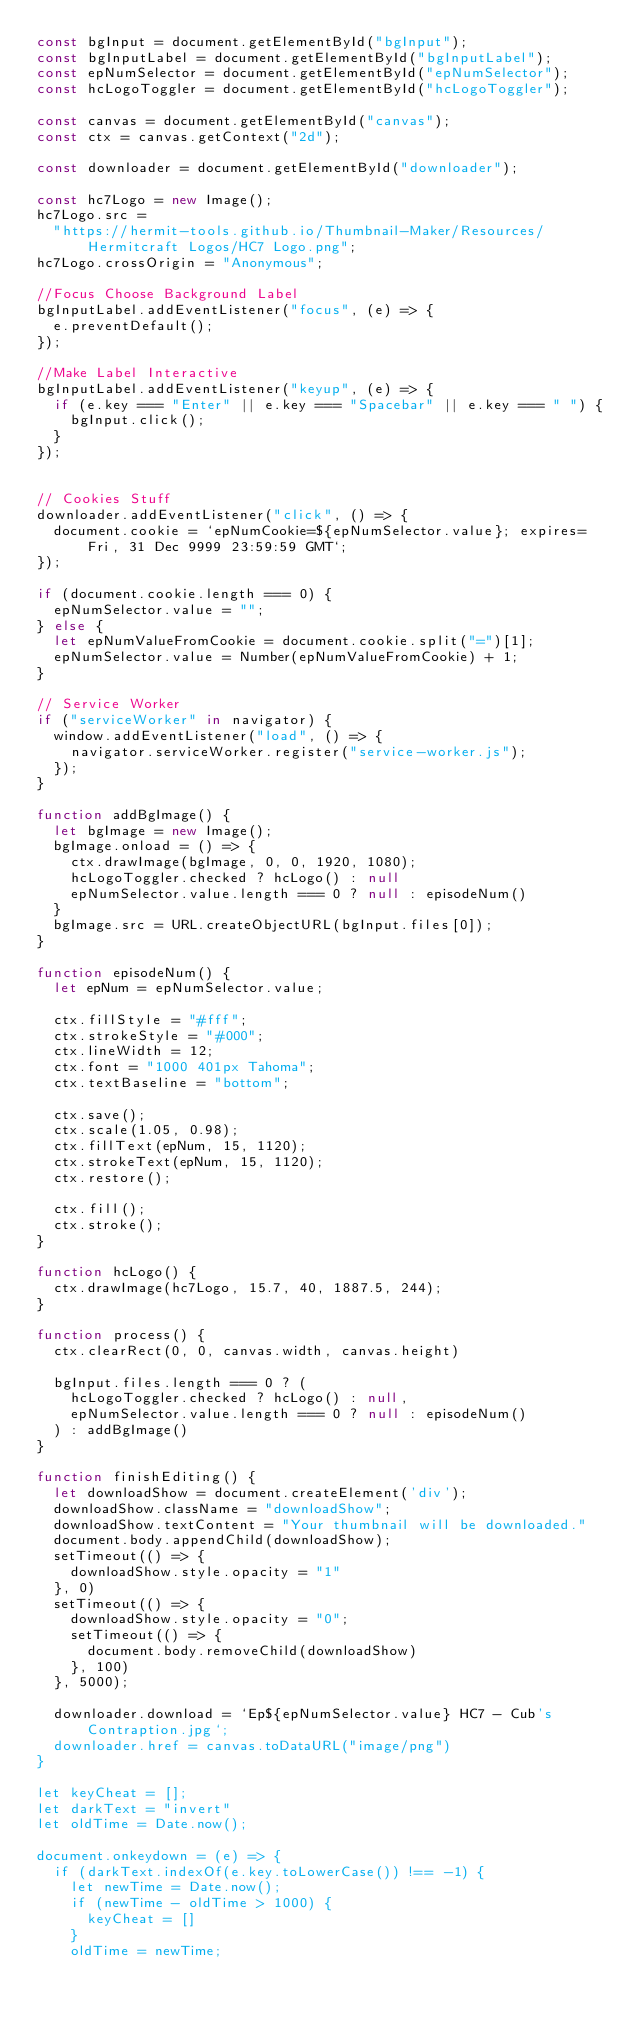Convert code to text. <code><loc_0><loc_0><loc_500><loc_500><_JavaScript_>const bgInput = document.getElementById("bgInput");
const bgInputLabel = document.getElementById("bgInputLabel");
const epNumSelector = document.getElementById("epNumSelector");
const hcLogoToggler = document.getElementById("hcLogoToggler");

const canvas = document.getElementById("canvas");
const ctx = canvas.getContext("2d");

const downloader = document.getElementById("downloader");

const hc7Logo = new Image();
hc7Logo.src =
  "https://hermit-tools.github.io/Thumbnail-Maker/Resources/Hermitcraft Logos/HC7 Logo.png";
hc7Logo.crossOrigin = "Anonymous";

//Focus Choose Background Label
bgInputLabel.addEventListener("focus", (e) => {
  e.preventDefault();
});

//Make Label Interactive
bgInputLabel.addEventListener("keyup", (e) => {
  if (e.key === "Enter" || e.key === "Spacebar" || e.key === " ") {
    bgInput.click();
  }
});


// Cookies Stuff
downloader.addEventListener("click", () => {
  document.cookie = `epNumCookie=${epNumSelector.value}; expires=Fri, 31 Dec 9999 23:59:59 GMT`;
});

if (document.cookie.length === 0) {
  epNumSelector.value = "";
} else {
  let epNumValueFromCookie = document.cookie.split("=")[1];
  epNumSelector.value = Number(epNumValueFromCookie) + 1;
}

// Service Worker
if ("serviceWorker" in navigator) {
  window.addEventListener("load", () => {
    navigator.serviceWorker.register("service-worker.js");
  });
}

function addBgImage() {
  let bgImage = new Image();
  bgImage.onload = () => {
    ctx.drawImage(bgImage, 0, 0, 1920, 1080);
    hcLogoToggler.checked ? hcLogo() : null
    epNumSelector.value.length === 0 ? null : episodeNum()
  }
  bgImage.src = URL.createObjectURL(bgInput.files[0]);
}

function episodeNum() {
  let epNum = epNumSelector.value;

  ctx.fillStyle = "#fff";
  ctx.strokeStyle = "#000";
  ctx.lineWidth = 12;
  ctx.font = "1000 401px Tahoma";
  ctx.textBaseline = "bottom";

  ctx.save();
  ctx.scale(1.05, 0.98);
  ctx.fillText(epNum, 15, 1120);
  ctx.strokeText(epNum, 15, 1120);
  ctx.restore();

  ctx.fill();
  ctx.stroke();
}

function hcLogo() {
  ctx.drawImage(hc7Logo, 15.7, 40, 1887.5, 244);
}

function process() {
  ctx.clearRect(0, 0, canvas.width, canvas.height)

  bgInput.files.length === 0 ? (
    hcLogoToggler.checked ? hcLogo() : null,
    epNumSelector.value.length === 0 ? null : episodeNum()
  ) : addBgImage()
}

function finishEditing() {
  let downloadShow = document.createElement('div');
  downloadShow.className = "downloadShow";
  downloadShow.textContent = "Your thumbnail will be downloaded."
  document.body.appendChild(downloadShow);
  setTimeout(() => {
    downloadShow.style.opacity = "1"
  }, 0)
  setTimeout(() => {
    downloadShow.style.opacity = "0";
    setTimeout(() => {
      document.body.removeChild(downloadShow)
    }, 100)
  }, 5000);

  downloader.download = `Ep${epNumSelector.value} HC7 - Cub's Contraption.jpg`;
  downloader.href = canvas.toDataURL("image/png")
}

let keyCheat = [];
let darkText = "invert"
let oldTime = Date.now();

document.onkeydown = (e) => {
  if (darkText.indexOf(e.key.toLowerCase()) !== -1) {
    let newTime = Date.now();
    if (newTime - oldTime > 1000) {
      keyCheat = []
    }
    oldTime = newTime;
</code> 